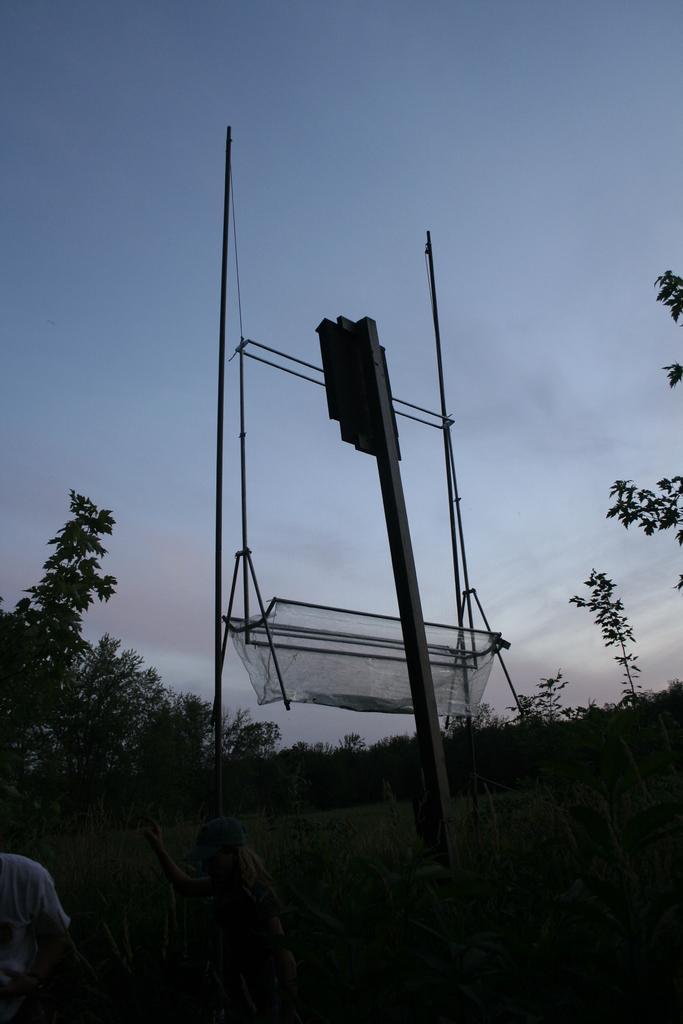Describe this image in one or two sentences. In the image there are many trees and in between the trees there is a grass surface and in the front there is some equipment and there are few people standing in front of that equipment. 